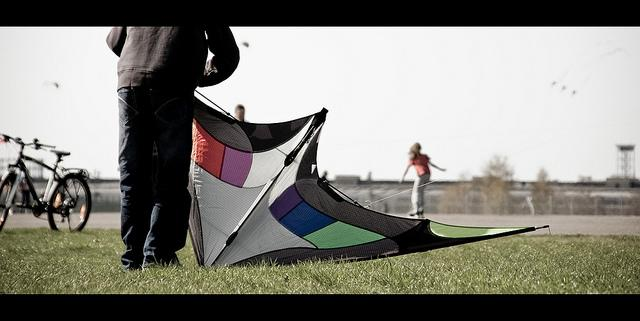How did the kite flyer get to the park? Please explain your reasoning. bicycle. The person used the bike. 